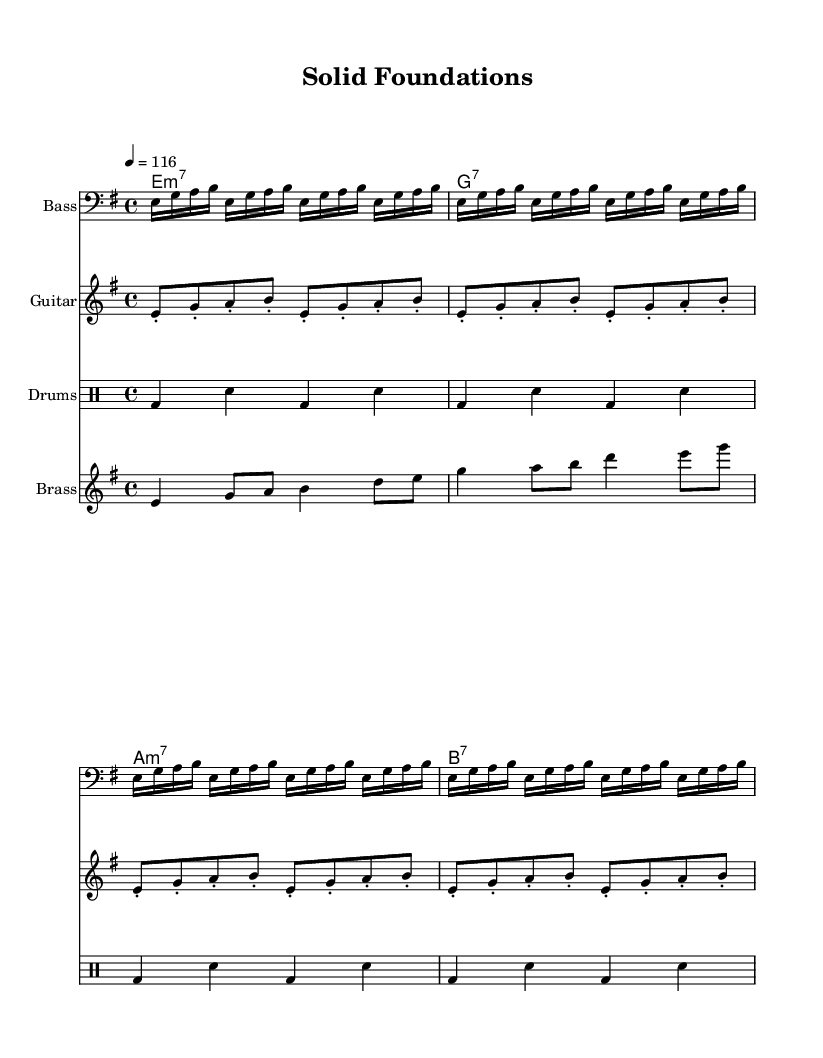What is the key signature of this music? The key signature is E minor, which has one sharp, F#. It can be identified at the beginning of the staff where the notes are placed.
Answer: E minor What is the time signature of this music? The time signature is 4/4, indicated at the beginning of the score. This means there are four beats per measure, and each quarter note receives one beat.
Answer: 4/4 What is the tempo marking for this piece? The tempo marking is quarter note equals 116, indicated in the tempo indication at the beginning of the music. This specifies the speed at which the piece should be played.
Answer: 116 How many measures are repeated in the bass line? The bass line has a repeat sign indicating it is repeated four times in the sheet music. This can be seen in the repeated unfold markings at the start of the bass line.
Answer: 4 What type of chords are used in the clavinet section? The chords in the clavinet section are minor seventh and dominant seventh chords, as indicated by the chord symbols above the music notation. These types of chords are characteristic of funk music, providing a rich harmonic base.
Answer: minor seventh and dominant seventh Describe the primary role of the brass in this track. The primary role of the brass in this track is melody. The brass staff contains a series of notes that create a lively and catchy melodic line, which complements the rhythmic elements provided by other instruments.
Answer: melody What rhythmic pattern is indicated for the drums? The rhythmic pattern for the drums consists of a bass drum and snare drum pattern, which is repeated throughout the piece, emphasizing the funk style's driving beat. This pattern can be observed in the drummode section of the sheet music.
Answer: bass and snare 